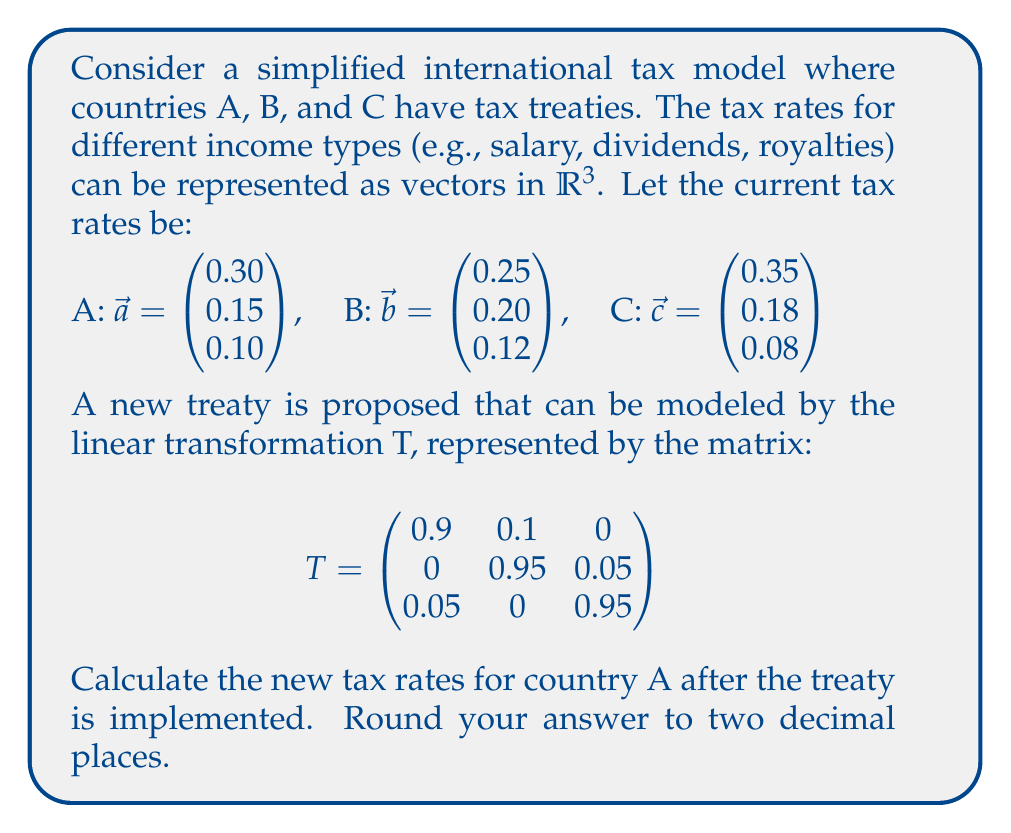Solve this math problem. To solve this problem, we need to apply the linear transformation T to the vector $\vec{a}$ representing country A's current tax rates. This can be done by matrix multiplication.

Step 1: Set up the matrix multiplication
$$T\vec{a} = \begin{pmatrix}
0.9 & 0.1 & 0 \\
0 & 0.95 & 0.05 \\
0.05 & 0 & 0.95
\end{pmatrix} \begin{pmatrix}
0.30 \\
0.15 \\
0.10
\end{pmatrix}$$

Step 2: Perform the matrix multiplication
$$(0.9 \times 0.30 + 0.1 \times 0.15 + 0 \times 0.10) = 0.285$$
$$(0 \times 0.30 + 0.95 \times 0.15 + 0.05 \times 0.10) = 0.1475$$
$$(0.05 \times 0.30 + 0 \times 0.15 + 0.95 \times 0.10) = 0.11$$

Step 3: Round the results to two decimal places
$$(0.29, 0.15, 0.11)$$

Therefore, the new tax rates for country A after the treaty implementation will be:
- Salary: 29%
- Dividends: 15%
- Royalties: 11%
Answer: $\begin{pmatrix} 0.29 \\ 0.15 \\ 0.11 \end{pmatrix}$ 